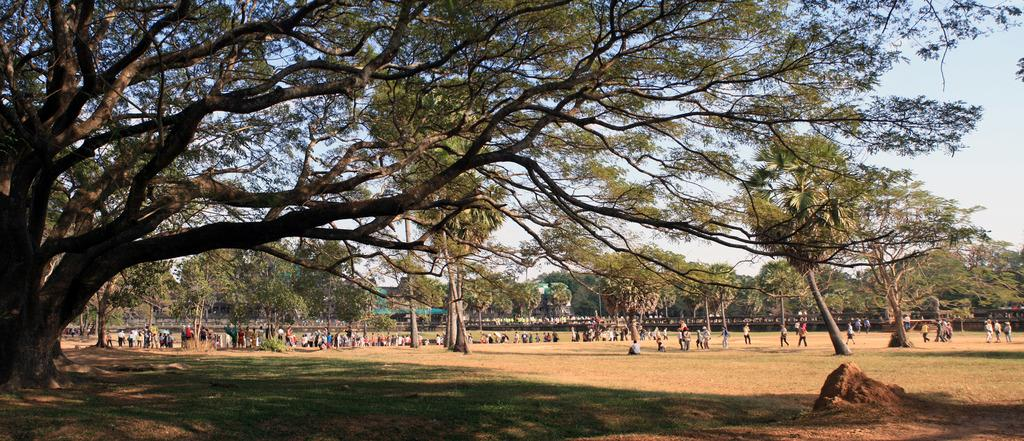What type of vegetation can be seen in the image? There are trees in the image. What are the people in the image doing? There are people walking and standing in the image. How would you describe the sky in the image? The sky is blue and cloudy in the image. Can you tell me how many teeth the trees have in the image? Trees do not have teeth, so this question cannot be answered. What type of addition is being performed by the people in the image? There is no indication of any addition being performed by the people in the image. 